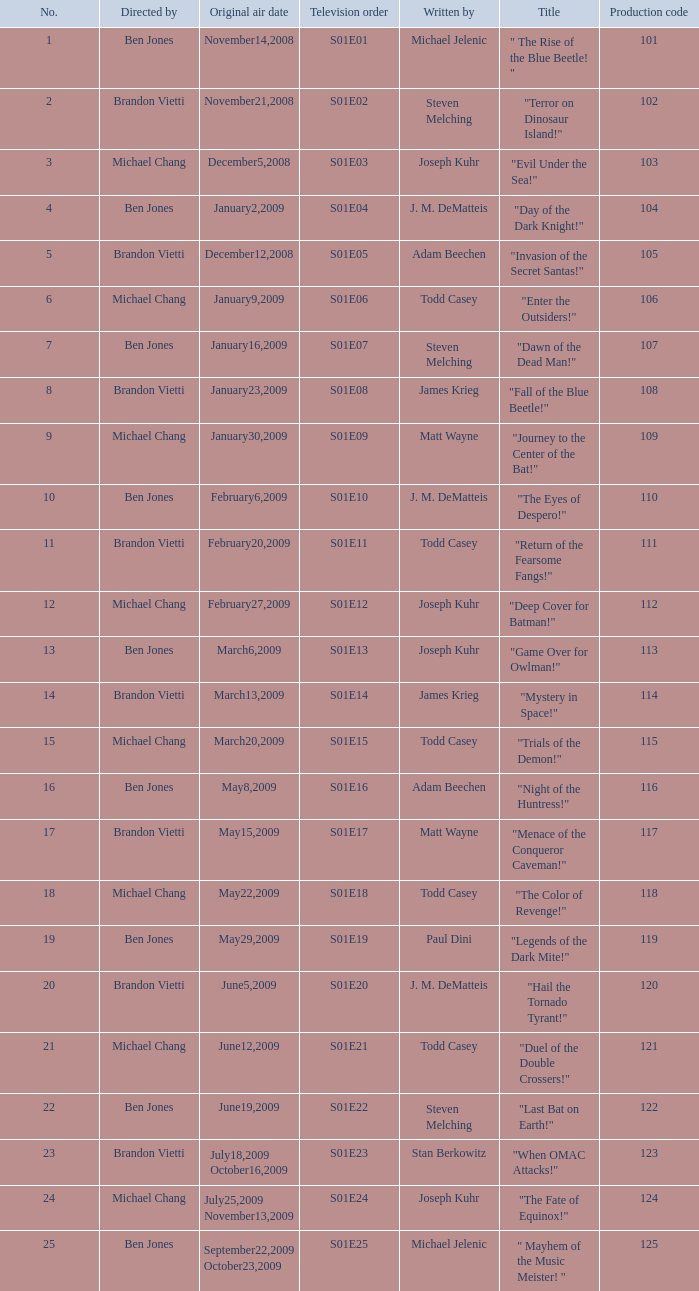Who wrote s01e06 Todd Casey. 